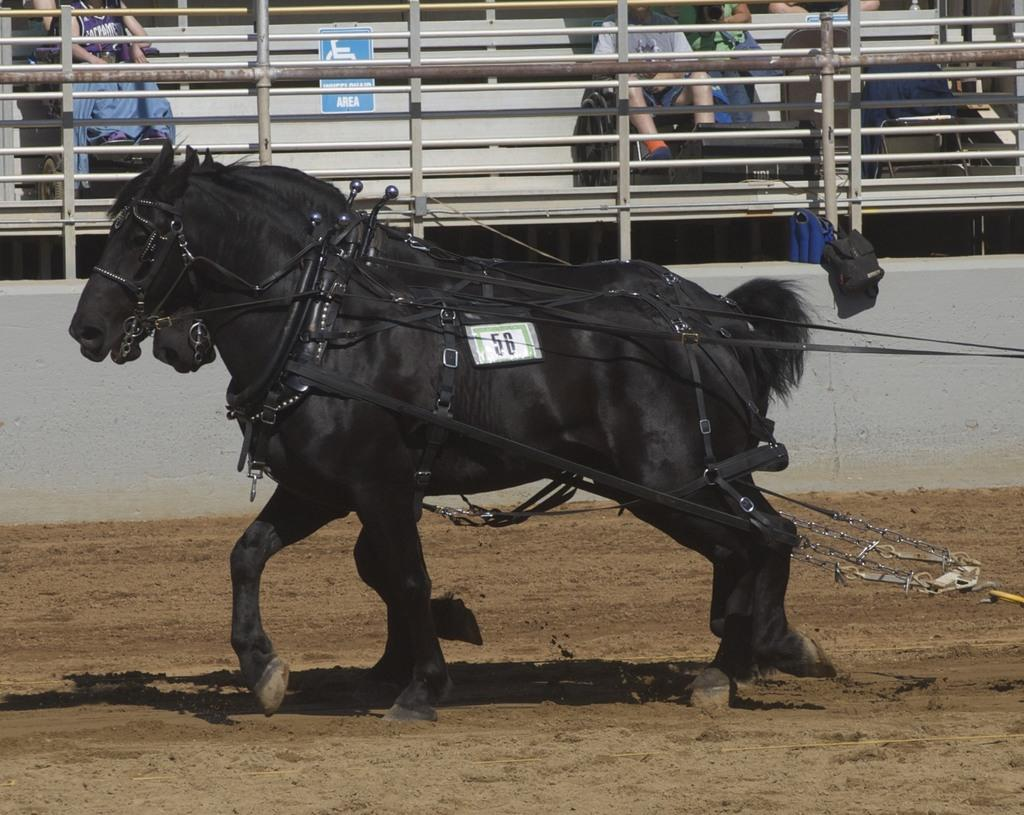What type of animals are in the image? There are black color horses in the image. What is attached to the horses? There are objects attached to the horses. What can be seen in the background of the image? There is a fence in the background of the image. Are there any people visible in the image? Yes, there are people in the background of the image. What is the income of the cattle in the image? There are no cattle present in the image; it features black color horses. How many times do the horses kick in the image? The image does not show the horses kicking, so it is not possible to determine how many times they kick. 